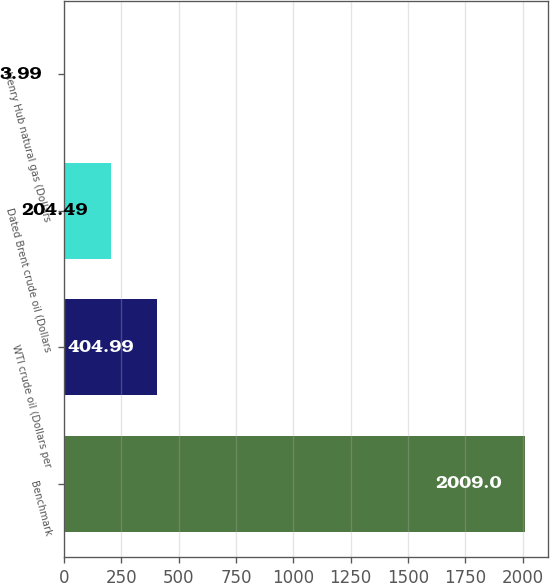Convert chart to OTSL. <chart><loc_0><loc_0><loc_500><loc_500><bar_chart><fcel>Benchmark<fcel>WTI crude oil (Dollars per<fcel>Dated Brent crude oil (Dollars<fcel>Henry Hub natural gas (Dollars<nl><fcel>2009<fcel>404.99<fcel>204.49<fcel>3.99<nl></chart> 